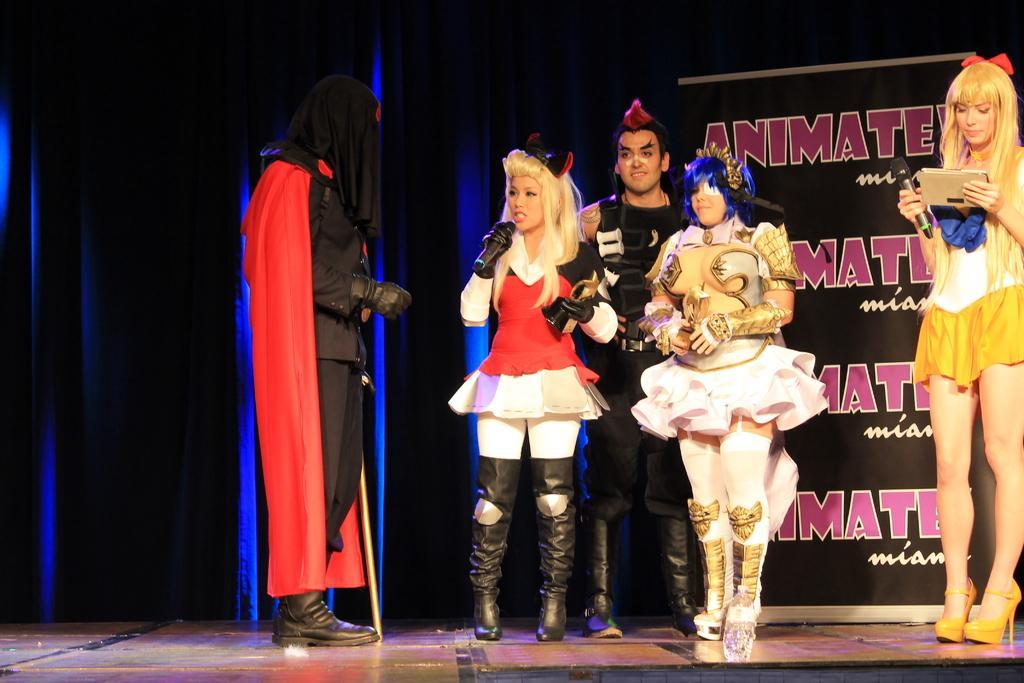In one or two sentences, can you explain what this image depicts? In this image, we can see people wearing costumes and they are holding mics and awards. On the right, there is a lady holding a mic and a tab. In the background, there is a curtain and we can see a banner. At the bottom, there is floor. 